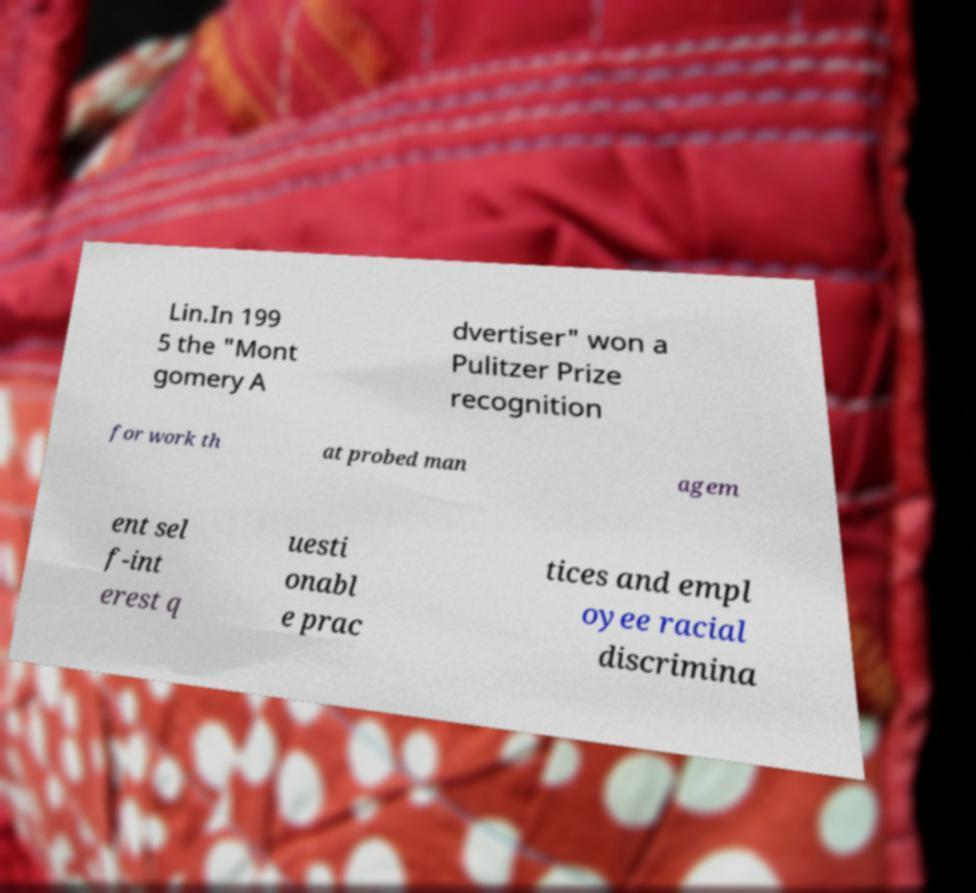Could you assist in decoding the text presented in this image and type it out clearly? Lin.In 199 5 the "Mont gomery A dvertiser" won a Pulitzer Prize recognition for work th at probed man agem ent sel f-int erest q uesti onabl e prac tices and empl oyee racial discrimina 